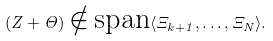<formula> <loc_0><loc_0><loc_500><loc_500>\left ( Z + \Theta \right ) \notin \text {span} \langle \Xi _ { k + 1 } , \dots , \Xi _ { N } \rangle .</formula> 